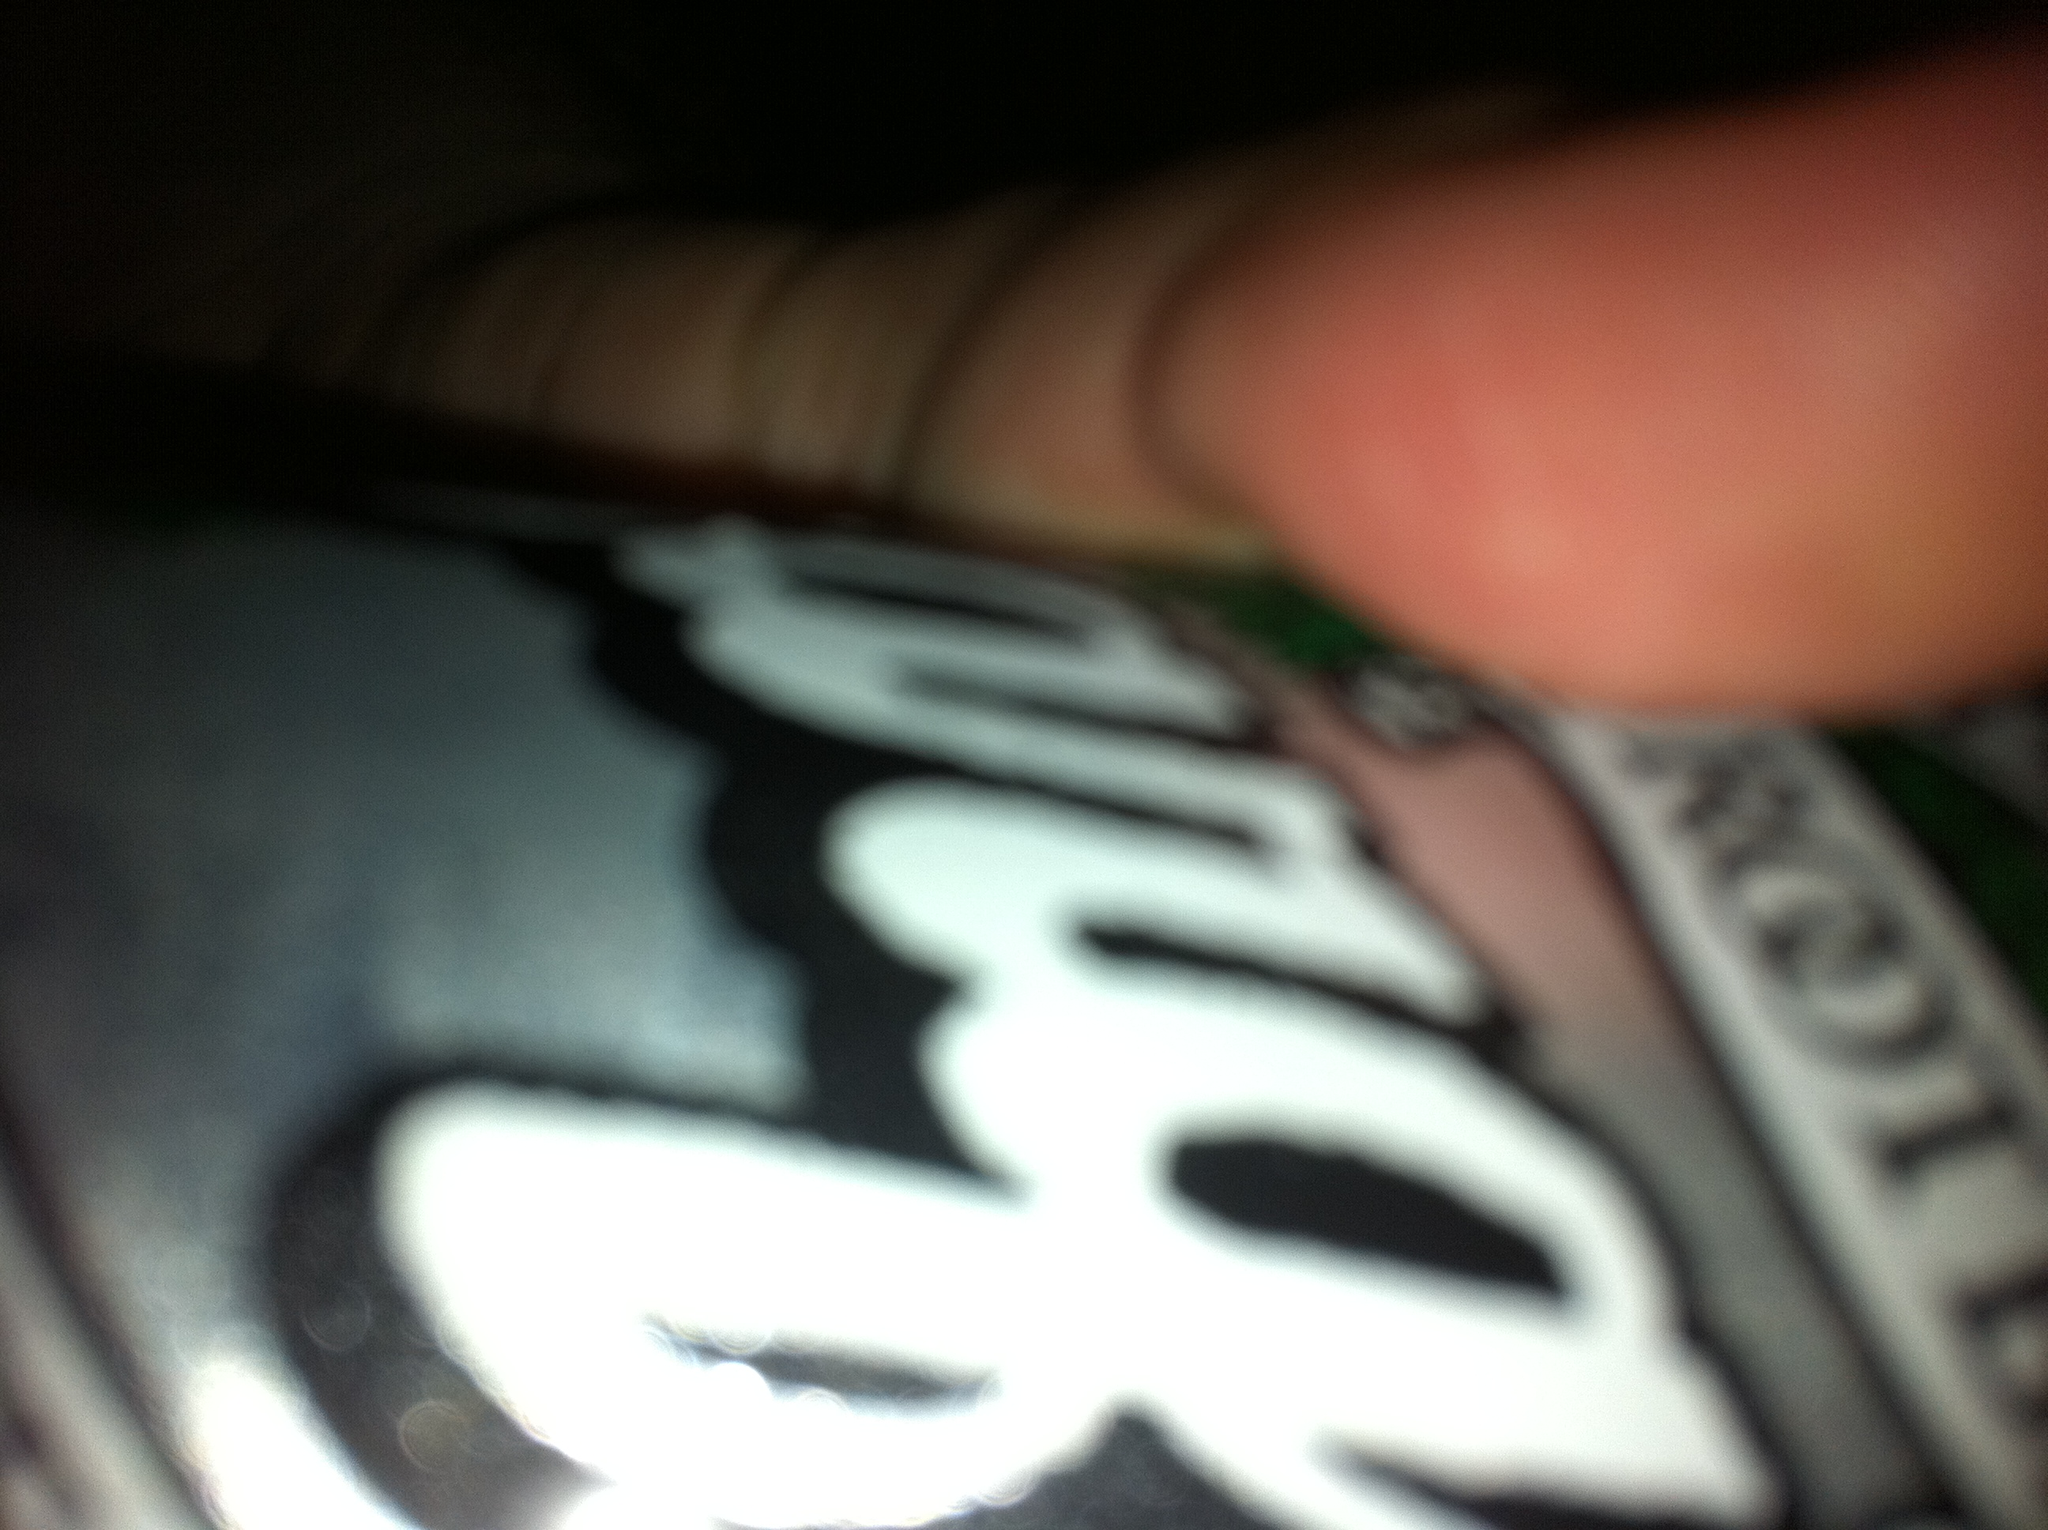Can you suggest a creative recipe using root beer? Sure! How about a Root Beer Float Cake? Here's what you'll need: 

Ingredients: 
- 1 box of vanilla cake mix 
- 1 can of root beer 
- 1 cup of whipped cream 
- Maraschino cherries for garnish 

Instructions: 
1. Preheat your oven according to the cake mix instructions. 
2. In a large bowl, combine the cake mix and root beer until well mixed. 
3. Pour the batter into a greased cake pan and bake according to the package instructions. 
4. Allow the cake to cool completely, then top with whipped cream and garnish with maraschino cherries. 
5. Serve slices of the cake with an extra scoop of whipped cream and enjoy! 